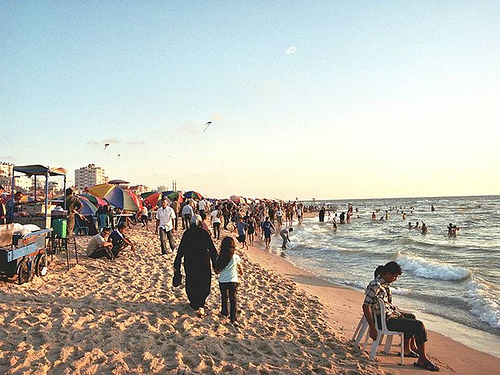On which side of the picture is the chair? The chair is located on the right side of the picture, standing solitary on the beach with a clear view of the sea. 